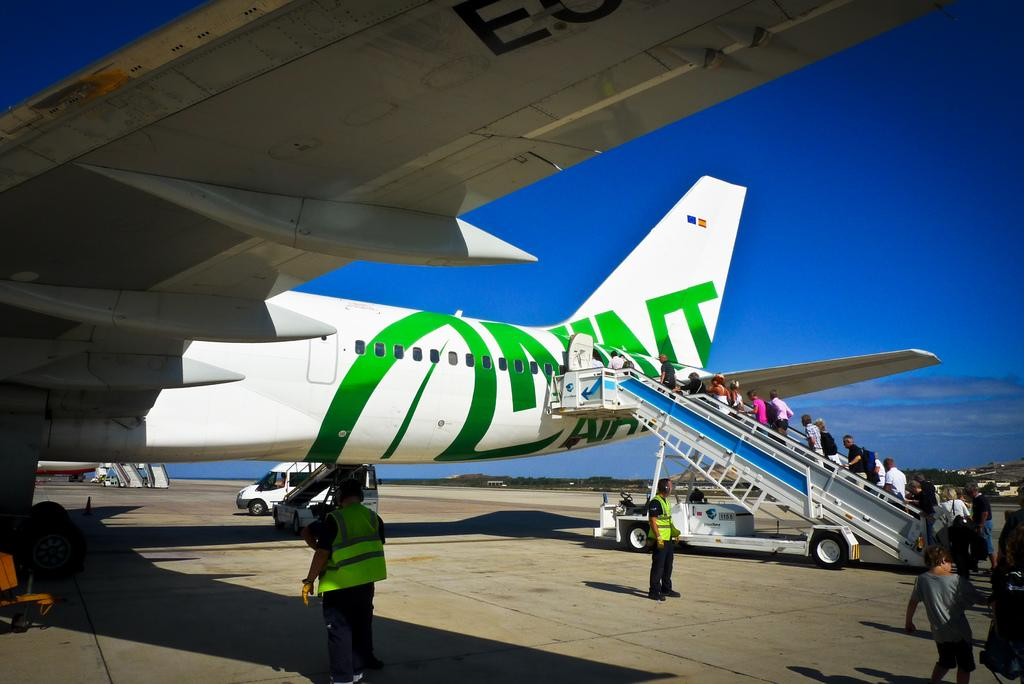<image>
Provide a brief description of the given image. A staircase being used to board a plane is numbered 1155. 